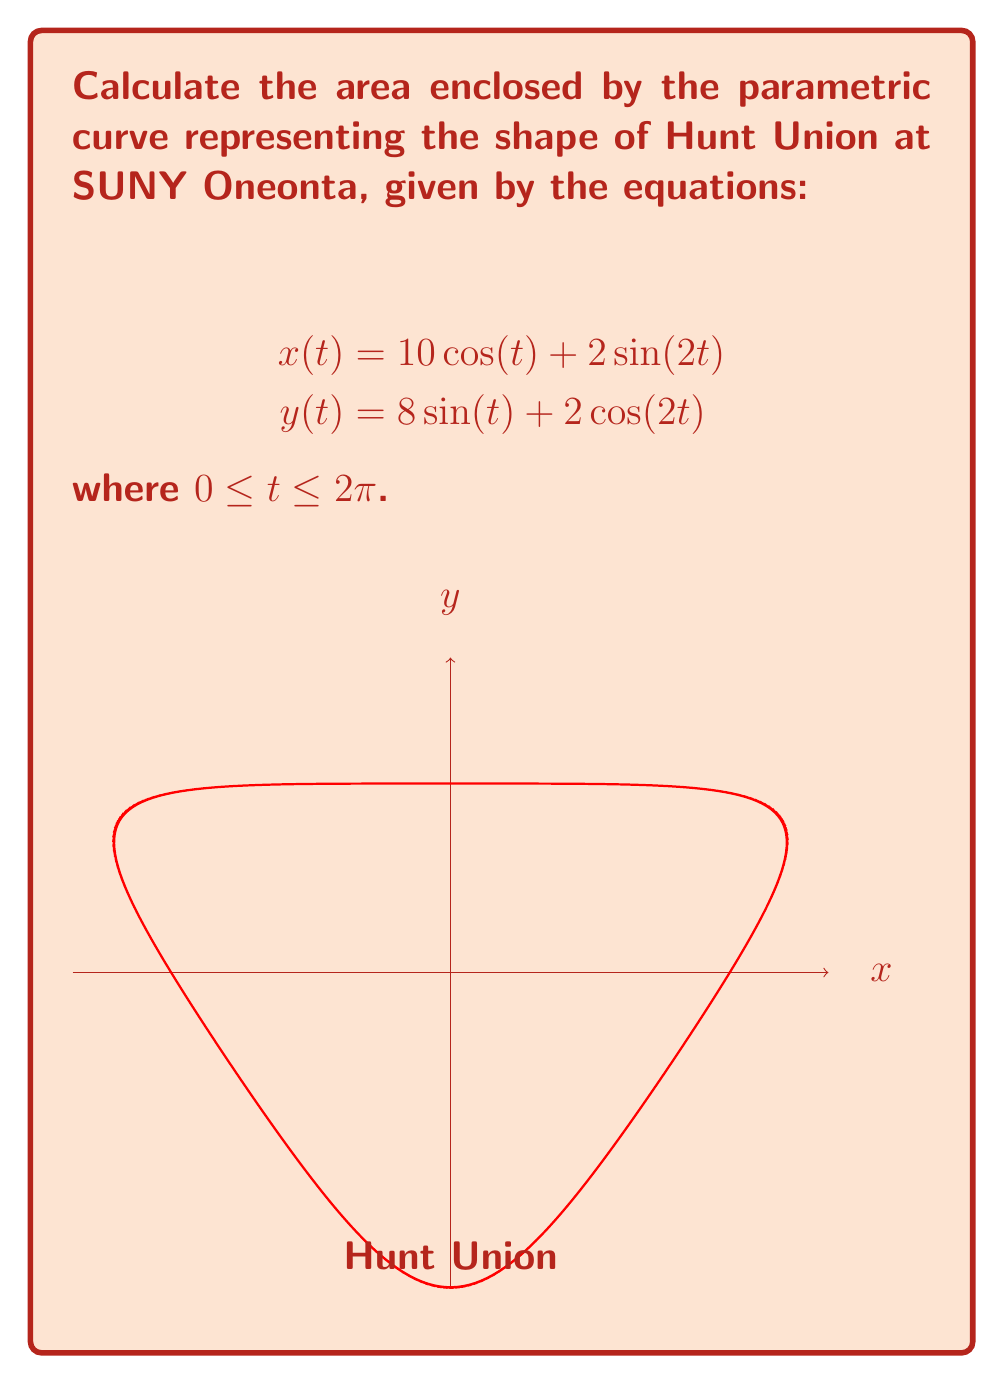Help me with this question. To calculate the area enclosed by a parametric curve, we can use the formula:

$$A = \frac{1}{2} \int_{0}^{2\pi} [x(t)y'(t) - y(t)x'(t)] dt$$

Step 1: Calculate $x'(t)$ and $y'(t)$
$$x'(t) = -10\sin(t) + 4\cos(2t)$$
$$y'(t) = 8\cos(t) - 4\sin(2t)$$

Step 2: Compute $x(t)y'(t)$ and $y(t)x'(t)$
$$x(t)y'(t) = (10\cos(t) + 2\sin(2t))(8\cos(t) - 4\sin(2t))$$
$$y(t)x'(t) = (8\sin(t) + 2\cos(2t))(-10\sin(t) + 4\cos(2t))$$

Step 3: Subtract $y(t)x'(t)$ from $x(t)y'(t)$
$$x(t)y'(t) - y(t)x'(t) = 80\cos^2(t) - 40\cos(t)\sin(2t) + 16\sin(2t)\cos(t) - 8\sin^2(2t) + 80\sin^2(t) + 32\sin(t)\cos(2t) - 20\cos(2t)\sin(t) - 8\cos^2(2t)$$

Step 4: Simplify using trigonometric identities
$$x(t)y'(t) - y(t)x'(t) = 80 + 12\sin(t)\cos(2t) - 40\cos(t)\sin(2t) - 8(\sin^2(2t) + \cos^2(2t))$$
$$= 80 + 12\sin(t)\cos(2t) - 40\cos(t)\sin(2t) - 8$$
$$= 72 + 12\sin(t)\cos(2t) - 40\cos(t)\sin(2t)$$

Step 5: Apply the integral
$$A = \frac{1}{2} \int_{0}^{2\pi} [72 + 12\sin(t)\cos(2t) - 40\cos(t)\sin(2t)] dt$$

Step 6: Evaluate the integral
The integral of 72 over $[0, 2\pi]$ is $72(2\pi) = 144\pi$.
The integrals of $\sin(t)\cos(2t)$ and $\cos(t)\sin(2t)$ over $[0, 2\pi]$ are both zero.

Therefore,
$$A = \frac{1}{2} (144\pi) = 72\pi$$
Answer: $72\pi$ square units 